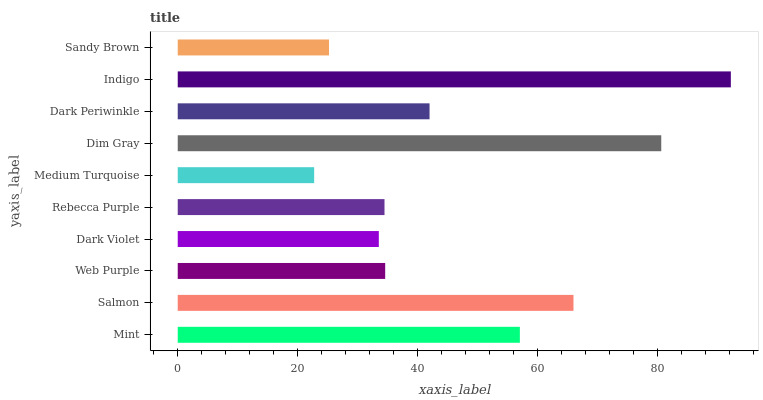Is Medium Turquoise the minimum?
Answer yes or no. Yes. Is Indigo the maximum?
Answer yes or no. Yes. Is Salmon the minimum?
Answer yes or no. No. Is Salmon the maximum?
Answer yes or no. No. Is Salmon greater than Mint?
Answer yes or no. Yes. Is Mint less than Salmon?
Answer yes or no. Yes. Is Mint greater than Salmon?
Answer yes or no. No. Is Salmon less than Mint?
Answer yes or no. No. Is Dark Periwinkle the high median?
Answer yes or no. Yes. Is Web Purple the low median?
Answer yes or no. Yes. Is Rebecca Purple the high median?
Answer yes or no. No. Is Dark Violet the low median?
Answer yes or no. No. 